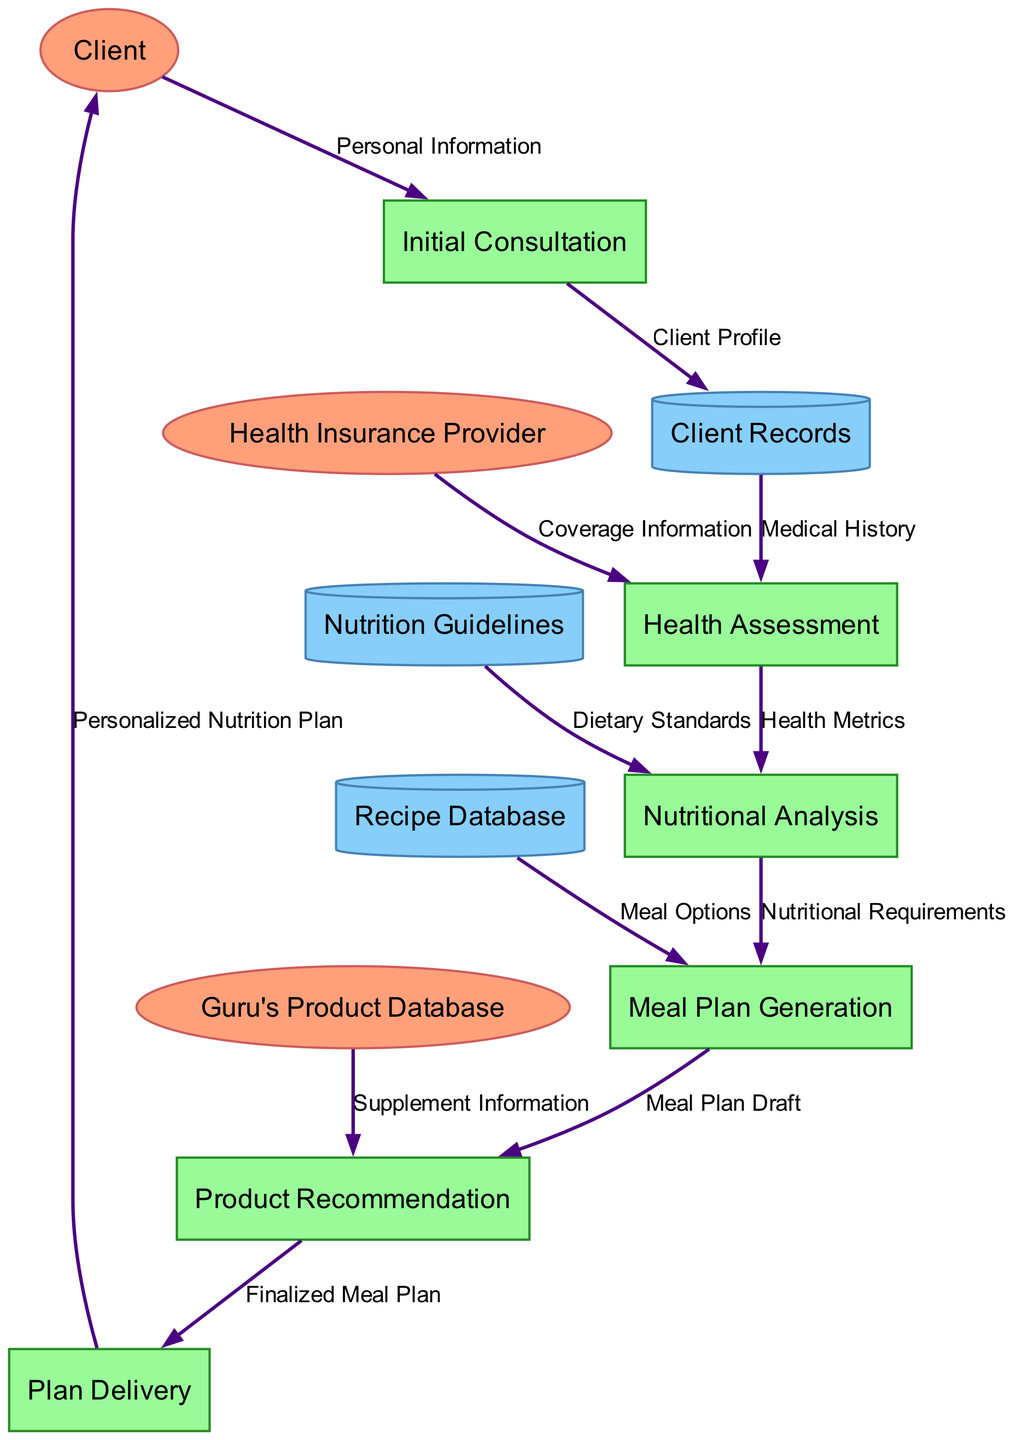what are the external entities in the diagram? The external entities in the diagram are listed under the "external_entities" section. They include the Client, Health Insurance Provider, and Guru's Product Database.
Answer: Client, Health Insurance Provider, Guru's Product Database how many processes are there in the consultation process? By counting the items in the "processes" section, there are six distinct processes involved in the consultation process.
Answer: six what data flow comes from the Health Insurance Provider? The data flow from the Health Insurance Provider goes to the Health Assessment process, carrying Coverage Information.
Answer: Coverage Information which data store is used for dietary standards? The data store used for dietary standards is the Nutrition Guidelines, as indicated by its connection to the Nutritional Analysis process.
Answer: Nutrition Guidelines what is delivered to the Client at the end of the process? At the end of the process, the Plan Delivery provides the Client with a Personalized Nutrition Plan. This is the final output of the entire consultation process.
Answer: Personalized Nutrition Plan how does the Meal Plan Generation process receive information? The Meal Plan Generation process receives information from two sources: the Nutritional Analysis process provides Nutritional Requirements, and the Recipe Database provides Meal Options.
Answer: Nutritional Requirements, Meal Options which process follows the Nutritional Analysis? The process that follows the Nutritional Analysis is the Meal Plan Generation, as depicted in the flow of data from Nutritional Analysis to Meal Plan Generation.
Answer: Meal Plan Generation how many data stores are used in the entire process? There are three data stores utilized throughout the process, including Client Records, Nutrition Guidelines, and Recipe Database.
Answer: three what is the relationship between Product Recommendation and Plan Delivery? The relationship is that the Product Recommendation process sends the Finalized Meal Plan to the Plan Delivery process, which is a subsequent step in the flow.
Answer: Finalized Meal Plan 